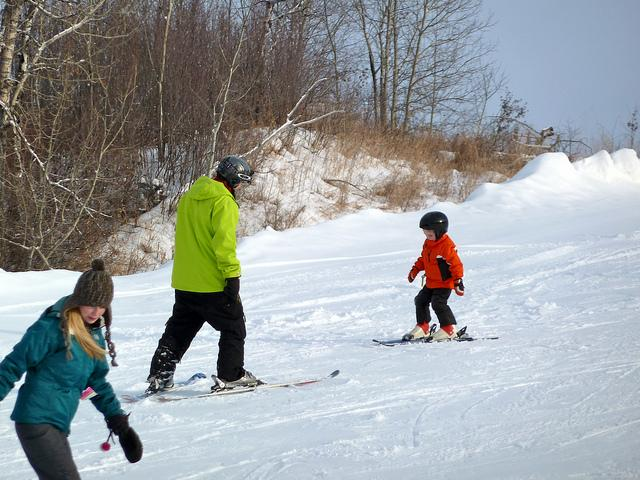The number of people here is called what? three 